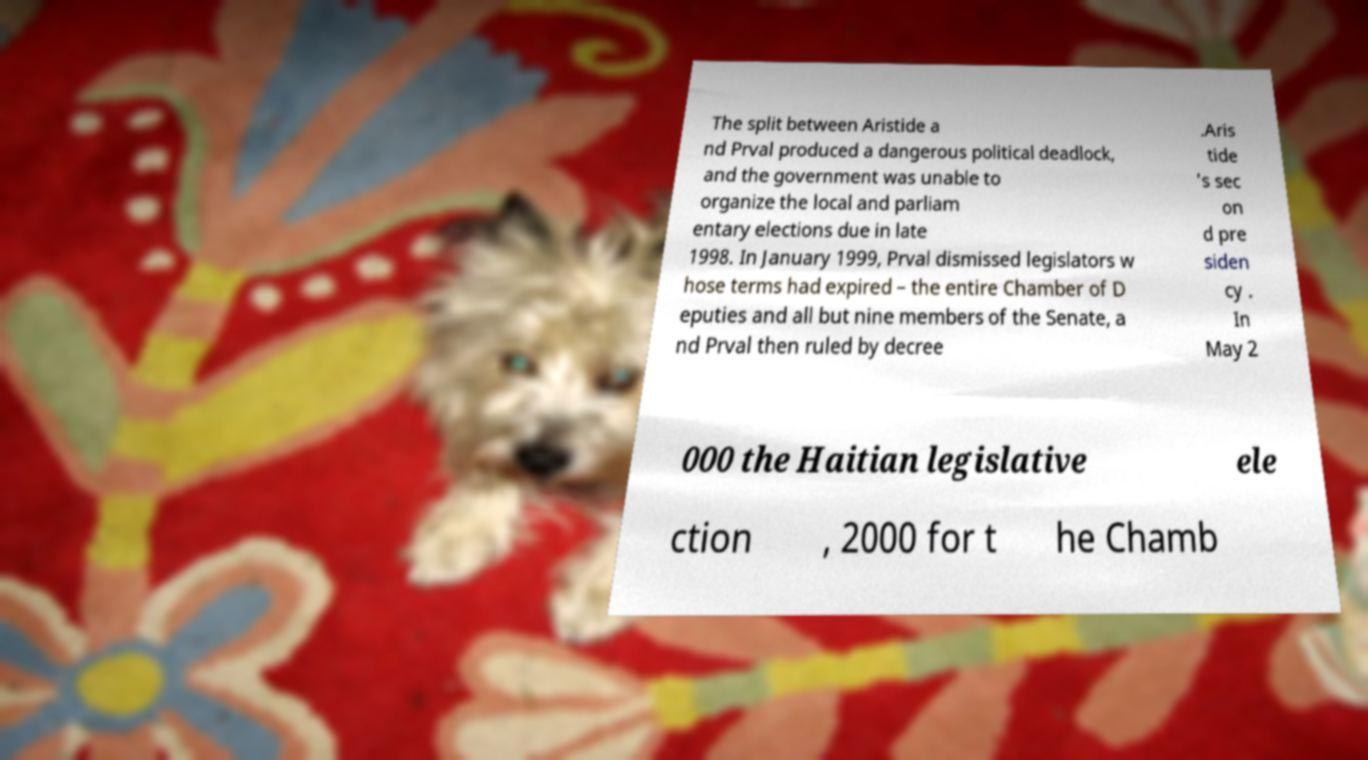Please identify and transcribe the text found in this image. The split between Aristide a nd Prval produced a dangerous political deadlock, and the government was unable to organize the local and parliam entary elections due in late 1998. In January 1999, Prval dismissed legislators w hose terms had expired – the entire Chamber of D eputies and all but nine members of the Senate, a nd Prval then ruled by decree .Aris tide 's sec on d pre siden cy . In May 2 000 the Haitian legislative ele ction , 2000 for t he Chamb 